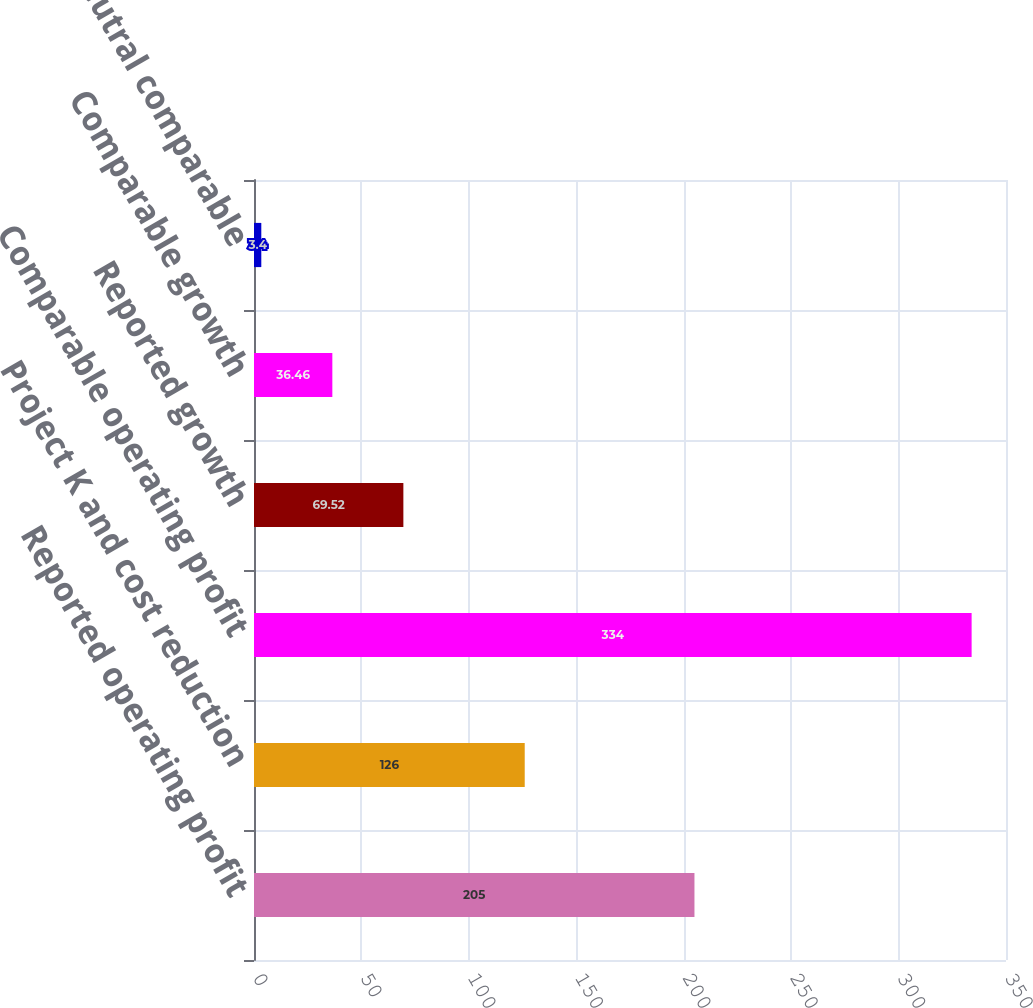<chart> <loc_0><loc_0><loc_500><loc_500><bar_chart><fcel>Reported operating profit<fcel>Project K and cost reduction<fcel>Comparable operating profit<fcel>Reported growth<fcel>Comparable growth<fcel>Currency-neutral comparable<nl><fcel>205<fcel>126<fcel>334<fcel>69.52<fcel>36.46<fcel>3.4<nl></chart> 